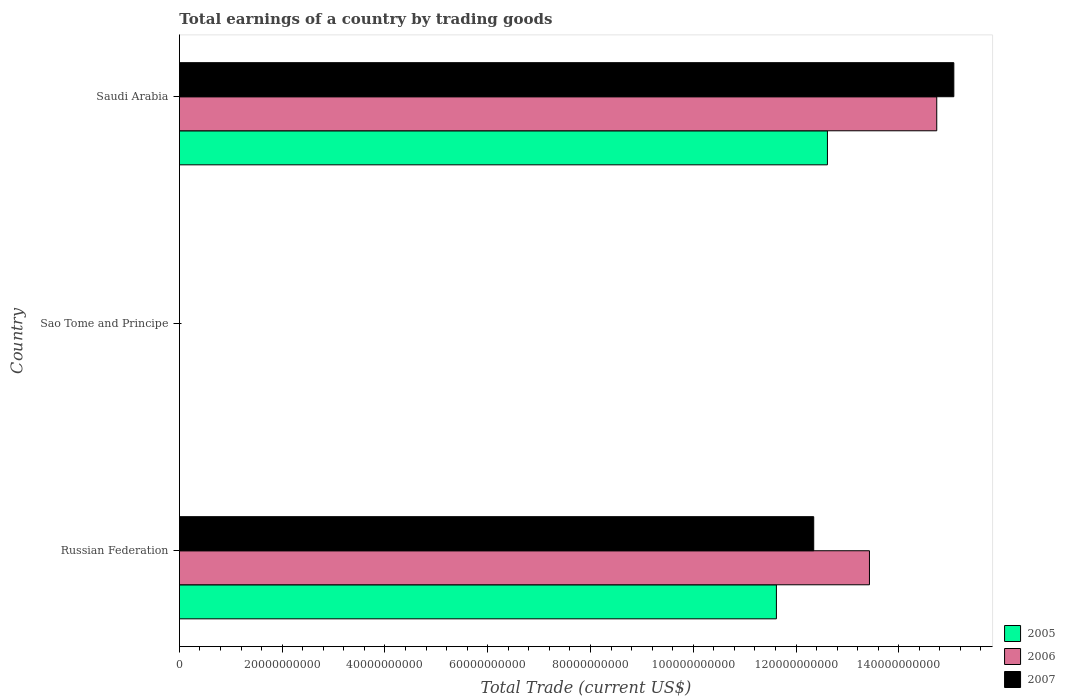How many different coloured bars are there?
Provide a succinct answer. 3. Are the number of bars per tick equal to the number of legend labels?
Provide a succinct answer. No. Are the number of bars on each tick of the Y-axis equal?
Give a very brief answer. No. How many bars are there on the 1st tick from the top?
Offer a very short reply. 3. How many bars are there on the 1st tick from the bottom?
Ensure brevity in your answer.  3. What is the label of the 2nd group of bars from the top?
Make the answer very short. Sao Tome and Principe. In how many cases, is the number of bars for a given country not equal to the number of legend labels?
Offer a terse response. 1. What is the total earnings in 2005 in Sao Tome and Principe?
Offer a terse response. 0. Across all countries, what is the maximum total earnings in 2006?
Provide a succinct answer. 1.47e+11. Across all countries, what is the minimum total earnings in 2007?
Offer a terse response. 0. In which country was the total earnings in 2006 maximum?
Ensure brevity in your answer.  Saudi Arabia. What is the total total earnings in 2006 in the graph?
Your answer should be very brief. 2.82e+11. What is the difference between the total earnings in 2006 in Russian Federation and that in Saudi Arabia?
Make the answer very short. -1.31e+1. What is the difference between the total earnings in 2005 in Saudi Arabia and the total earnings in 2006 in Russian Federation?
Give a very brief answer. -8.18e+09. What is the average total earnings in 2007 per country?
Your answer should be very brief. 9.14e+1. What is the difference between the total earnings in 2005 and total earnings in 2006 in Saudi Arabia?
Your answer should be very brief. -2.13e+1. What is the ratio of the total earnings in 2005 in Russian Federation to that in Saudi Arabia?
Make the answer very short. 0.92. What is the difference between the highest and the lowest total earnings in 2005?
Ensure brevity in your answer.  1.26e+11. In how many countries, is the total earnings in 2005 greater than the average total earnings in 2005 taken over all countries?
Provide a short and direct response. 2. Is it the case that in every country, the sum of the total earnings in 2005 and total earnings in 2006 is greater than the total earnings in 2007?
Offer a terse response. No. How many bars are there?
Keep it short and to the point. 6. How many countries are there in the graph?
Make the answer very short. 3. Are the values on the major ticks of X-axis written in scientific E-notation?
Your answer should be compact. No. Does the graph contain any zero values?
Keep it short and to the point. Yes. How many legend labels are there?
Make the answer very short. 3. How are the legend labels stacked?
Keep it short and to the point. Vertical. What is the title of the graph?
Offer a very short reply. Total earnings of a country by trading goods. Does "2003" appear as one of the legend labels in the graph?
Your answer should be very brief. No. What is the label or title of the X-axis?
Your answer should be very brief. Total Trade (current US$). What is the label or title of the Y-axis?
Your response must be concise. Country. What is the Total Trade (current US$) in 2005 in Russian Federation?
Ensure brevity in your answer.  1.16e+11. What is the Total Trade (current US$) in 2006 in Russian Federation?
Keep it short and to the point. 1.34e+11. What is the Total Trade (current US$) of 2007 in Russian Federation?
Give a very brief answer. 1.23e+11. What is the Total Trade (current US$) in 2005 in Sao Tome and Principe?
Your answer should be very brief. 0. What is the Total Trade (current US$) in 2005 in Saudi Arabia?
Your response must be concise. 1.26e+11. What is the Total Trade (current US$) in 2006 in Saudi Arabia?
Give a very brief answer. 1.47e+11. What is the Total Trade (current US$) of 2007 in Saudi Arabia?
Your answer should be very brief. 1.51e+11. Across all countries, what is the maximum Total Trade (current US$) in 2005?
Offer a terse response. 1.26e+11. Across all countries, what is the maximum Total Trade (current US$) in 2006?
Your answer should be compact. 1.47e+11. Across all countries, what is the maximum Total Trade (current US$) of 2007?
Provide a succinct answer. 1.51e+11. What is the total Total Trade (current US$) of 2005 in the graph?
Make the answer very short. 2.42e+11. What is the total Total Trade (current US$) in 2006 in the graph?
Your answer should be very brief. 2.82e+11. What is the total Total Trade (current US$) of 2007 in the graph?
Provide a short and direct response. 2.74e+11. What is the difference between the Total Trade (current US$) in 2005 in Russian Federation and that in Saudi Arabia?
Provide a short and direct response. -9.93e+09. What is the difference between the Total Trade (current US$) in 2006 in Russian Federation and that in Saudi Arabia?
Offer a terse response. -1.31e+1. What is the difference between the Total Trade (current US$) in 2007 in Russian Federation and that in Saudi Arabia?
Provide a succinct answer. -2.73e+1. What is the difference between the Total Trade (current US$) of 2005 in Russian Federation and the Total Trade (current US$) of 2006 in Saudi Arabia?
Make the answer very short. -3.12e+1. What is the difference between the Total Trade (current US$) of 2005 in Russian Federation and the Total Trade (current US$) of 2007 in Saudi Arabia?
Ensure brevity in your answer.  -3.45e+1. What is the difference between the Total Trade (current US$) in 2006 in Russian Federation and the Total Trade (current US$) in 2007 in Saudi Arabia?
Your answer should be compact. -1.64e+1. What is the average Total Trade (current US$) in 2005 per country?
Ensure brevity in your answer.  8.08e+1. What is the average Total Trade (current US$) in 2006 per country?
Ensure brevity in your answer.  9.39e+1. What is the average Total Trade (current US$) of 2007 per country?
Your response must be concise. 9.14e+1. What is the difference between the Total Trade (current US$) in 2005 and Total Trade (current US$) in 2006 in Russian Federation?
Your answer should be compact. -1.81e+1. What is the difference between the Total Trade (current US$) in 2005 and Total Trade (current US$) in 2007 in Russian Federation?
Provide a succinct answer. -7.26e+09. What is the difference between the Total Trade (current US$) in 2006 and Total Trade (current US$) in 2007 in Russian Federation?
Your answer should be compact. 1.08e+1. What is the difference between the Total Trade (current US$) of 2005 and Total Trade (current US$) of 2006 in Saudi Arabia?
Provide a succinct answer. -2.13e+1. What is the difference between the Total Trade (current US$) in 2005 and Total Trade (current US$) in 2007 in Saudi Arabia?
Make the answer very short. -2.46e+1. What is the difference between the Total Trade (current US$) of 2006 and Total Trade (current US$) of 2007 in Saudi Arabia?
Your response must be concise. -3.32e+09. What is the ratio of the Total Trade (current US$) of 2005 in Russian Federation to that in Saudi Arabia?
Your answer should be very brief. 0.92. What is the ratio of the Total Trade (current US$) in 2006 in Russian Federation to that in Saudi Arabia?
Offer a terse response. 0.91. What is the ratio of the Total Trade (current US$) of 2007 in Russian Federation to that in Saudi Arabia?
Offer a terse response. 0.82. What is the difference between the highest and the lowest Total Trade (current US$) in 2005?
Offer a terse response. 1.26e+11. What is the difference between the highest and the lowest Total Trade (current US$) of 2006?
Offer a terse response. 1.47e+11. What is the difference between the highest and the lowest Total Trade (current US$) in 2007?
Give a very brief answer. 1.51e+11. 